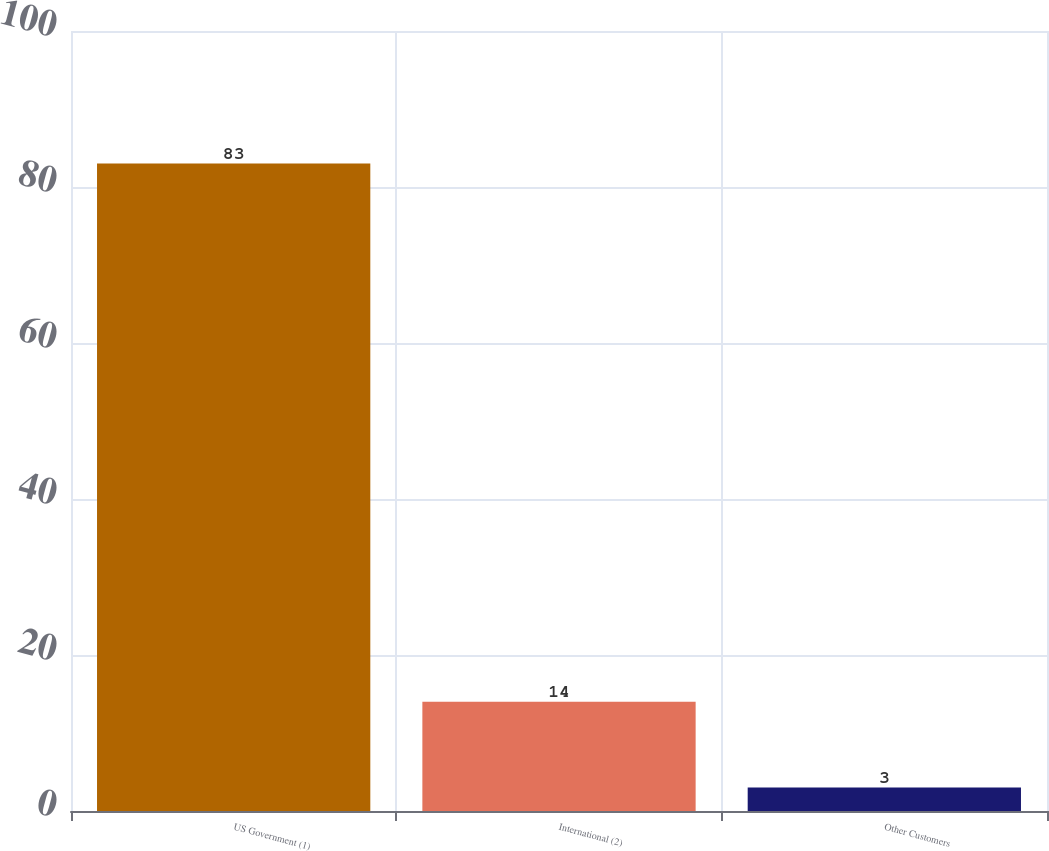Convert chart. <chart><loc_0><loc_0><loc_500><loc_500><bar_chart><fcel>US Government (1)<fcel>International (2)<fcel>Other Customers<nl><fcel>83<fcel>14<fcel>3<nl></chart> 